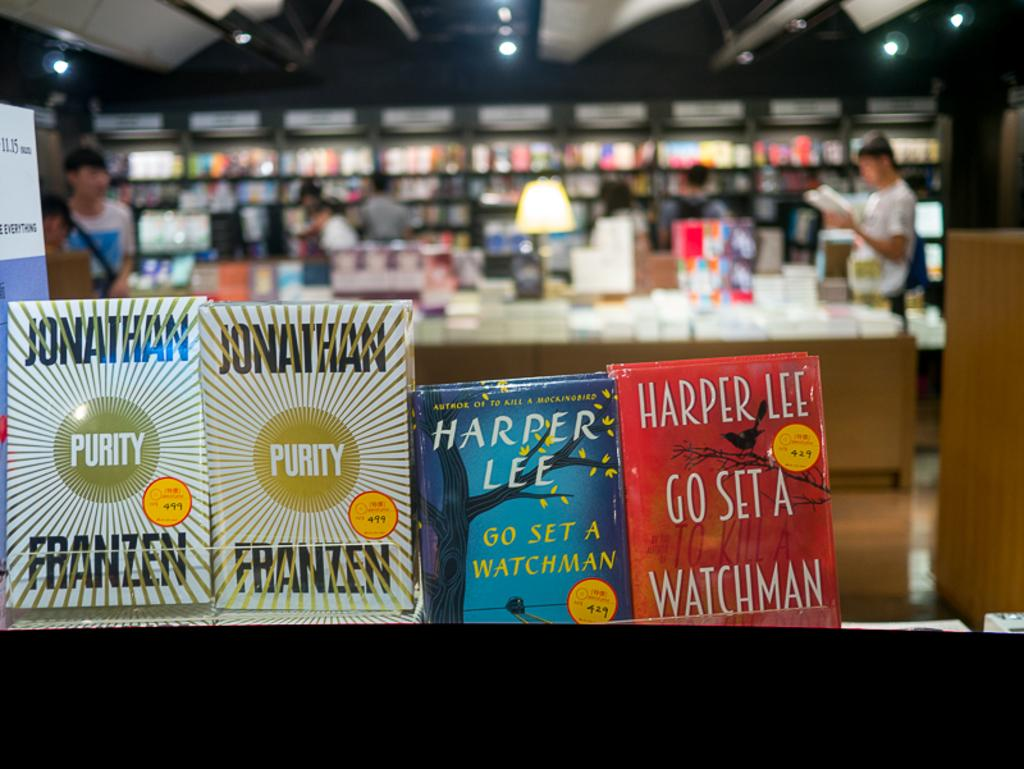<image>
Present a compact description of the photo's key features. Two out of the four books on display are titled Purity 